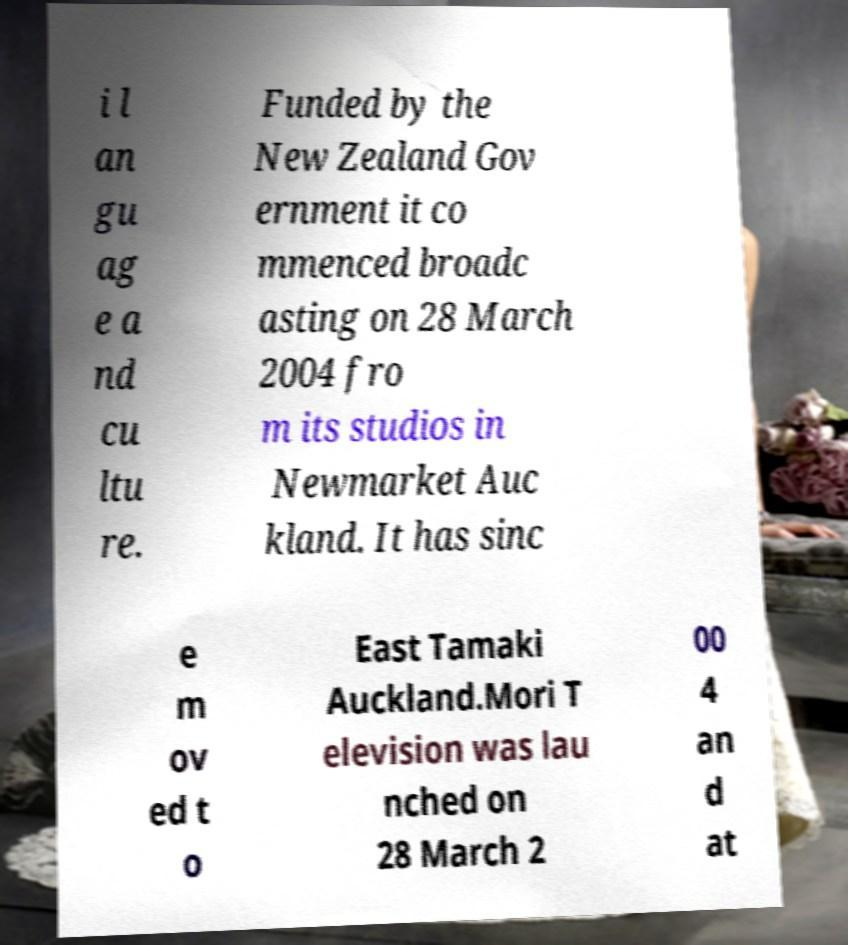What messages or text are displayed in this image? I need them in a readable, typed format. i l an gu ag e a nd cu ltu re. Funded by the New Zealand Gov ernment it co mmenced broadc asting on 28 March 2004 fro m its studios in Newmarket Auc kland. It has sinc e m ov ed t o East Tamaki Auckland.Mori T elevision was lau nched on 28 March 2 00 4 an d at 